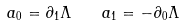Convert formula to latex. <formula><loc_0><loc_0><loc_500><loc_500>a _ { 0 } = \partial _ { 1 } \Lambda \quad a _ { 1 } = - \partial _ { 0 } \Lambda</formula> 